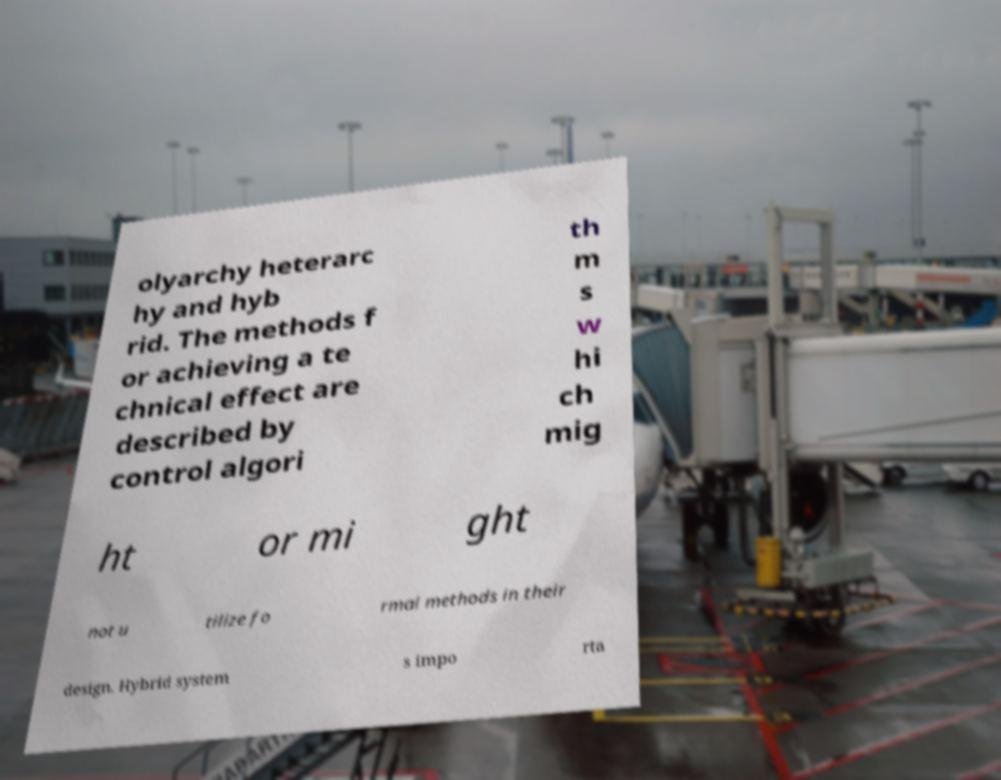Please identify and transcribe the text found in this image. olyarchy heterarc hy and hyb rid. The methods f or achieving a te chnical effect are described by control algori th m s w hi ch mig ht or mi ght not u tilize fo rmal methods in their design. Hybrid system s impo rta 